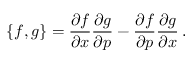Convert formula to latex. <formula><loc_0><loc_0><loc_500><loc_500>\{ f , g \} = \frac { \partial f } { \partial x } \frac { \partial g } { \partial p } - \frac { \partial f } { \partial p } \frac { \partial g } { \partial x } \, .</formula> 